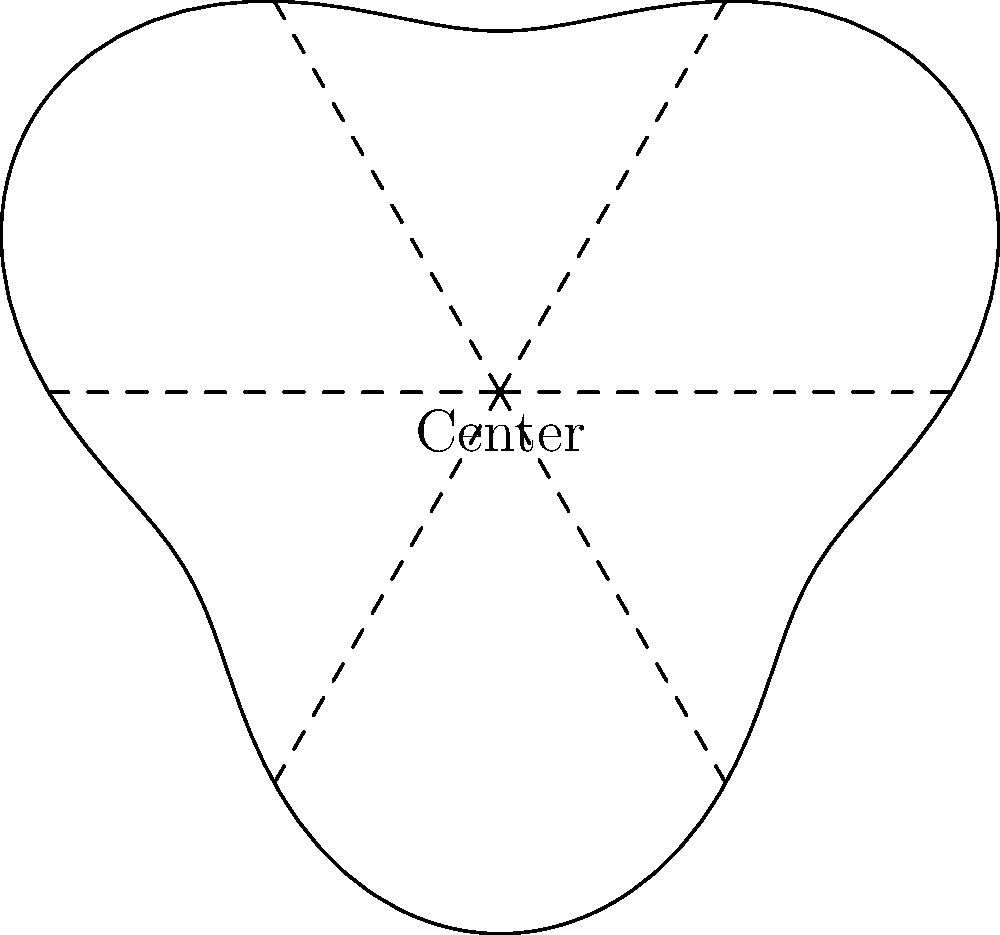As a property developer planning a circular community in the Bronx, you're using the polar equation $r = 150 + 30\sin(3\theta)$ (in meters) to design the perimeter of the development. The equation creates a flower-like shape with 6 "petals". If you want to place amenities at the points furthest from the center, at what angles (in radians) should they be located? To find the angles where the amenities should be placed, we need to determine where the radius is at its maximum. Let's approach this step-by-step:

1) The general equation is $r = 150 + 30\sin(3\theta)$

2) The radius will be at its maximum when $\sin(3\theta)$ is at its maximum, which occurs when $3\theta = \frac{\pi}{2}, \frac{5\pi}{2}, \frac{9\pi}{2}$, etc.

3) Solving for $\theta$:
   $\theta = \frac{\pi}{6}, \frac{5\pi}{6}, \frac{3\pi}{2}$

4) Due to the periodicity of sine, these values will repeat every $2\pi/3$ radians.

5) Therefore, the complete set of angles (in radians) where the radius is at its maximum is:

   $\{\frac{\pi}{6}, \frac{\pi}{2}, \frac{5\pi}{6}, \frac{7\pi}{6}, \frac{3\pi}{2}, \frac{11\pi}{6}\}$

These angles correspond to the tips of the six "petals" in the polar graph, which are the points furthest from the center of the development.
Answer: $\{\frac{\pi}{6}, \frac{\pi}{2}, \frac{5\pi}{6}, \frac{7\pi}{6}, \frac{3\pi}{2}, \frac{11\pi}{6}\}$ radians 